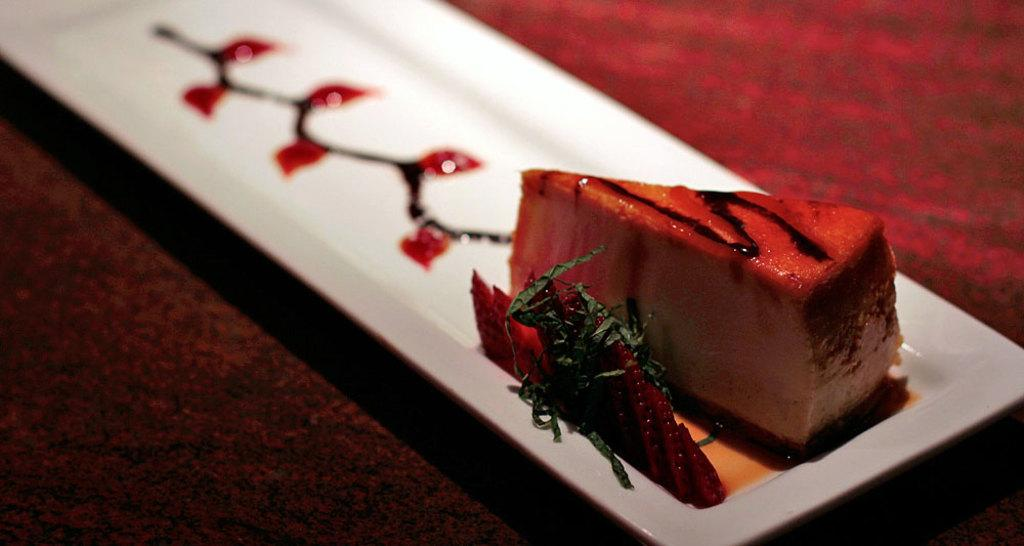What is present in the image related to food? There is food in the image. How is the food arranged or contained? The food is in a tray. What can be seen in the background of the image? There appears to be a table in the background of the image. What type of copper material can be seen in the image? There is no copper material present in the image. How many mice are visible in the image? There are no mice present in the image. 